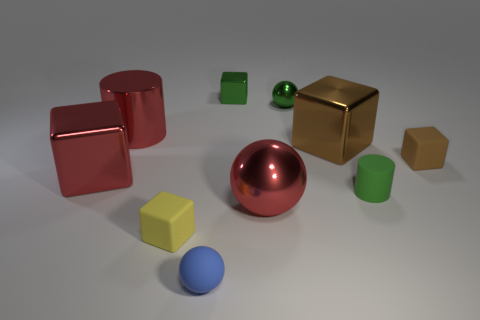What is the size of the shiny sphere that is the same color as the large cylinder?
Ensure brevity in your answer.  Large. There is a big red cylinder; are there any blue balls in front of it?
Keep it short and to the point. Yes. What number of objects are either balls or cylinders?
Your answer should be compact. 5. What number of other objects are there of the same size as the green matte cylinder?
Keep it short and to the point. 5. What number of small cubes are on the right side of the small blue sphere and left of the green rubber cylinder?
Provide a succinct answer. 1. There is a cube left of the yellow cube; is it the same size as the metallic ball behind the big metallic cylinder?
Give a very brief answer. No. There is a ball behind the large brown metallic object; what size is it?
Provide a short and direct response. Small. How many objects are large metallic objects that are behind the brown matte block or red metallic things that are behind the rubber sphere?
Ensure brevity in your answer.  4. Are there any other things that have the same color as the small rubber sphere?
Give a very brief answer. No. Is the number of red metallic cylinders on the right side of the red metallic ball the same as the number of brown metallic cubes that are on the left side of the tiny blue matte sphere?
Offer a terse response. Yes. 